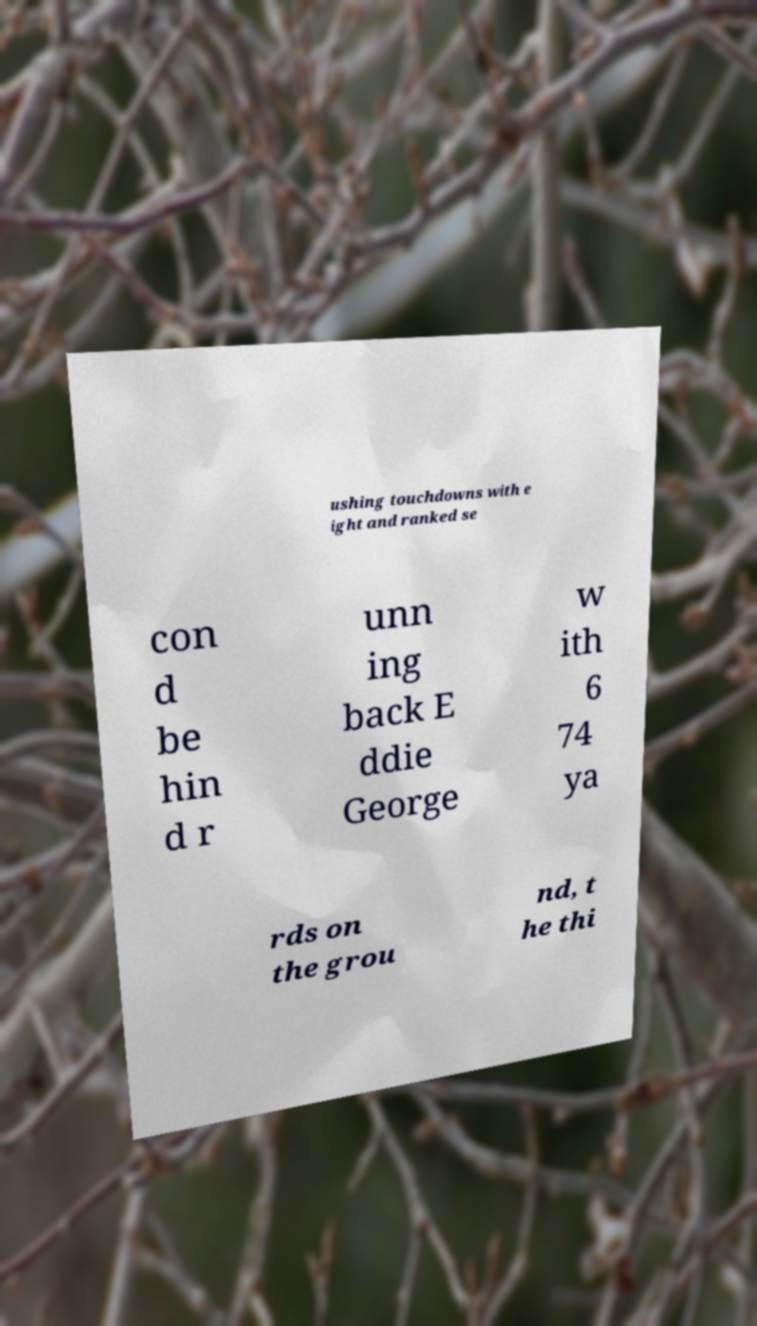Can you accurately transcribe the text from the provided image for me? ushing touchdowns with e ight and ranked se con d be hin d r unn ing back E ddie George w ith 6 74 ya rds on the grou nd, t he thi 